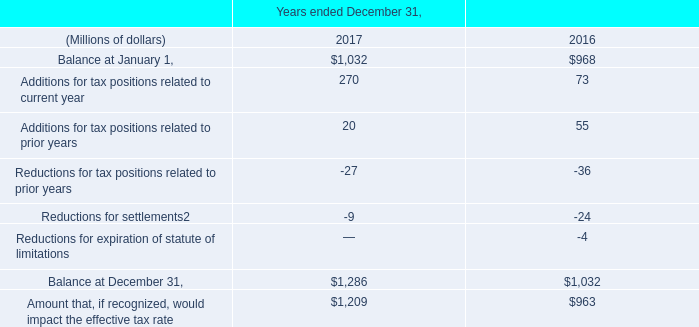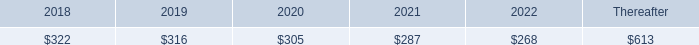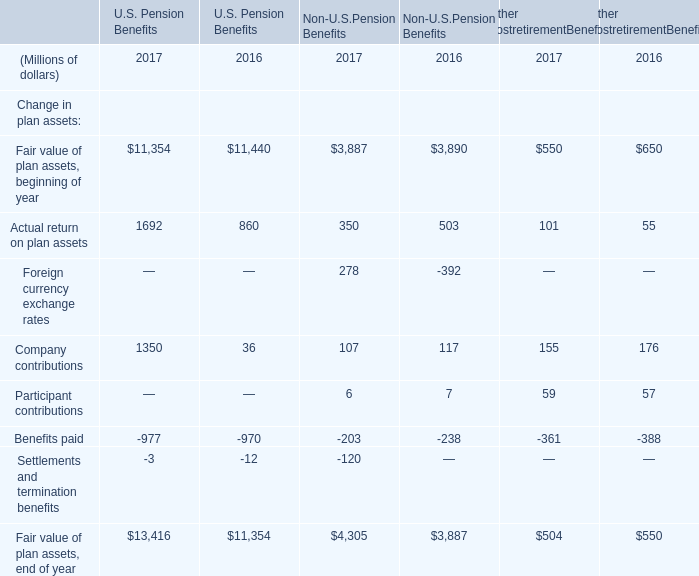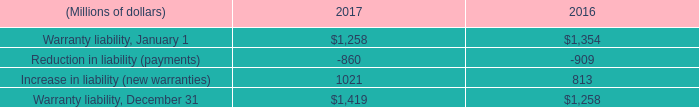what is the expected growth rate in amortization expense in 2017? 
Computations: ((323 - 326) / 326)
Answer: -0.0092. 